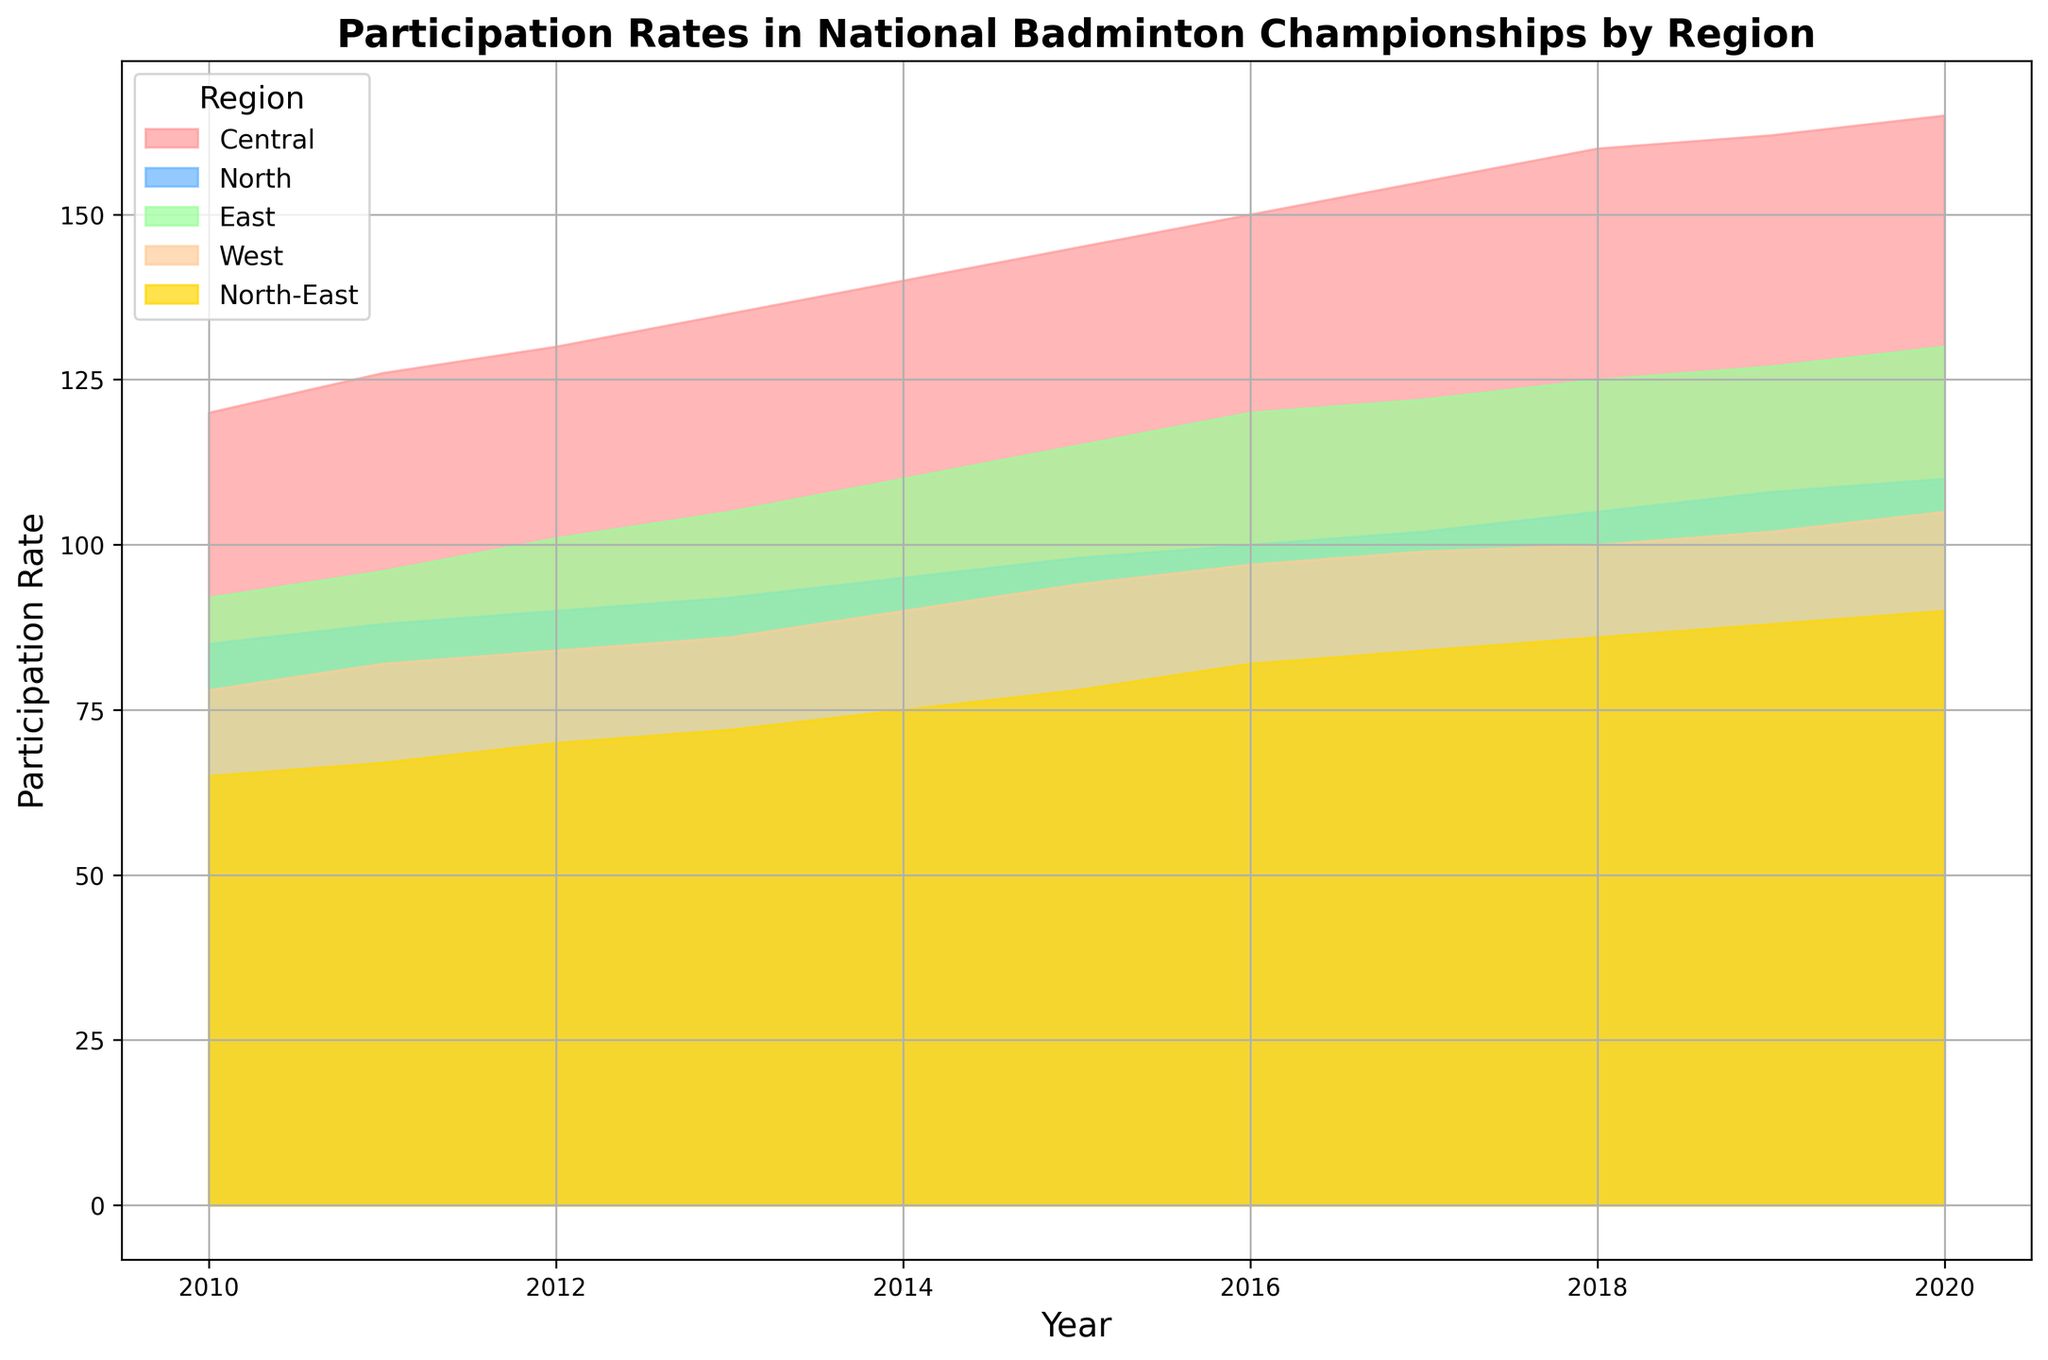What is the participation rate for the Central region in 2020? Refer to the highest point of the area in red which represents the Central region. In 2020, the participation rate is given as 165.
Answer: 165 Which region had the lowest participation rate in 2013? Look at the diagram for 2013 and identify the areas that represent each region. The smallest area in that year is for the North-East region (yellow), which has a participation rate of 72.
Answer: North-East How has the participation rate in the East region changed from 2010 to 2020? Compare the height of the green area (representing East) at the start (2010) and end (2020) of the chart. In 2010, the rate is 92 and in 2020 it is 130; the change is 130 - 92 = 38.
Answer: Increased by 38 What is the sum of participation rates for all regions in 2015? Add the heights of all the different colored areas for 2015. Central: 145, North: 98, East: 115, West: 94, North-East: 78. The sum is 145 + 98 + 115 + 94 + 78 = 530.
Answer: 530 Has the participation rate in the North-East region ever exceeded 85? Look at the yellow area over the entire span of the chart. The maximum rate in the North-East region occurs in 2020 at 90, which does indeed exceed 85.
Answer: Yes Which year showed the highest overall participation rate when combined across all regions? For each year, visually sum the heights of all the regions' areas. The tallest cumulative height appears in 2020.
Answer: 2020 Between 2015 and 2019, which region saw the largest increase in participation rate? Calculate changes for each region: Central (162 - 145 = 17), North (108 - 98 = 10), East (127 - 115 = 12), West (102 - 94 = 8), North-East (88 - 78 = 10). The Central region has the largest increase.
Answer: Central What is the average participation rate for the West region from 2010 to 2020? Add the rates for West from 2010 to 2020 and divide by the number of years. (78 + 82 + 84 + 86 + 90 + 94 + 97 + 99 + 100 + 102 + 105) / 11 = 91.
Answer: 91 By how much did the participation rate in the North-East region increase annually on average over the entire period? Calculate the average annual increase: (90 - 65) / (2020-2010) = 25 / 10 = 2.5.
Answer: 2.5 per year Which region had the smallest year-to-year variability in participation rate? Look for the region where the area chart appears smoothly continuous and has the smallest fluctuations visually. The North region (blue) shows the smallest variability.
Answer: North 